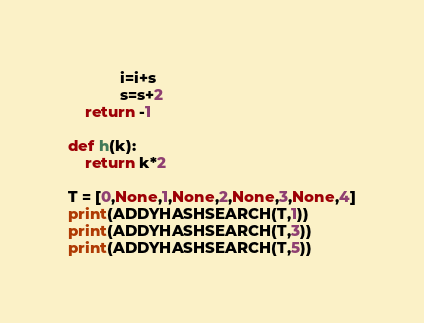<code> <loc_0><loc_0><loc_500><loc_500><_Python_>            i=i+s
            s=s+2
    return -1

def h(k):
    return k*2

T = [0,None,1,None,2,None,3,None,4]
print(ADDYHASHSEARCH(T,1))
print(ADDYHASHSEARCH(T,3))
print(ADDYHASHSEARCH(T,5))</code> 